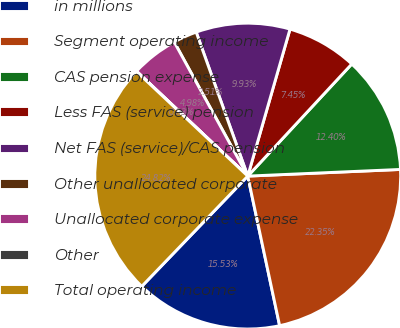Convert chart to OTSL. <chart><loc_0><loc_0><loc_500><loc_500><pie_chart><fcel>in millions<fcel>Segment operating income<fcel>CAS pension expense<fcel>Less FAS (service) pension<fcel>Net FAS (service)/CAS pension<fcel>Other unallocated corporate<fcel>Unallocated corporate expense<fcel>Other<fcel>Total operating income<nl><fcel>15.53%<fcel>22.35%<fcel>12.4%<fcel>7.45%<fcel>9.93%<fcel>2.51%<fcel>4.98%<fcel>0.03%<fcel>24.82%<nl></chart> 